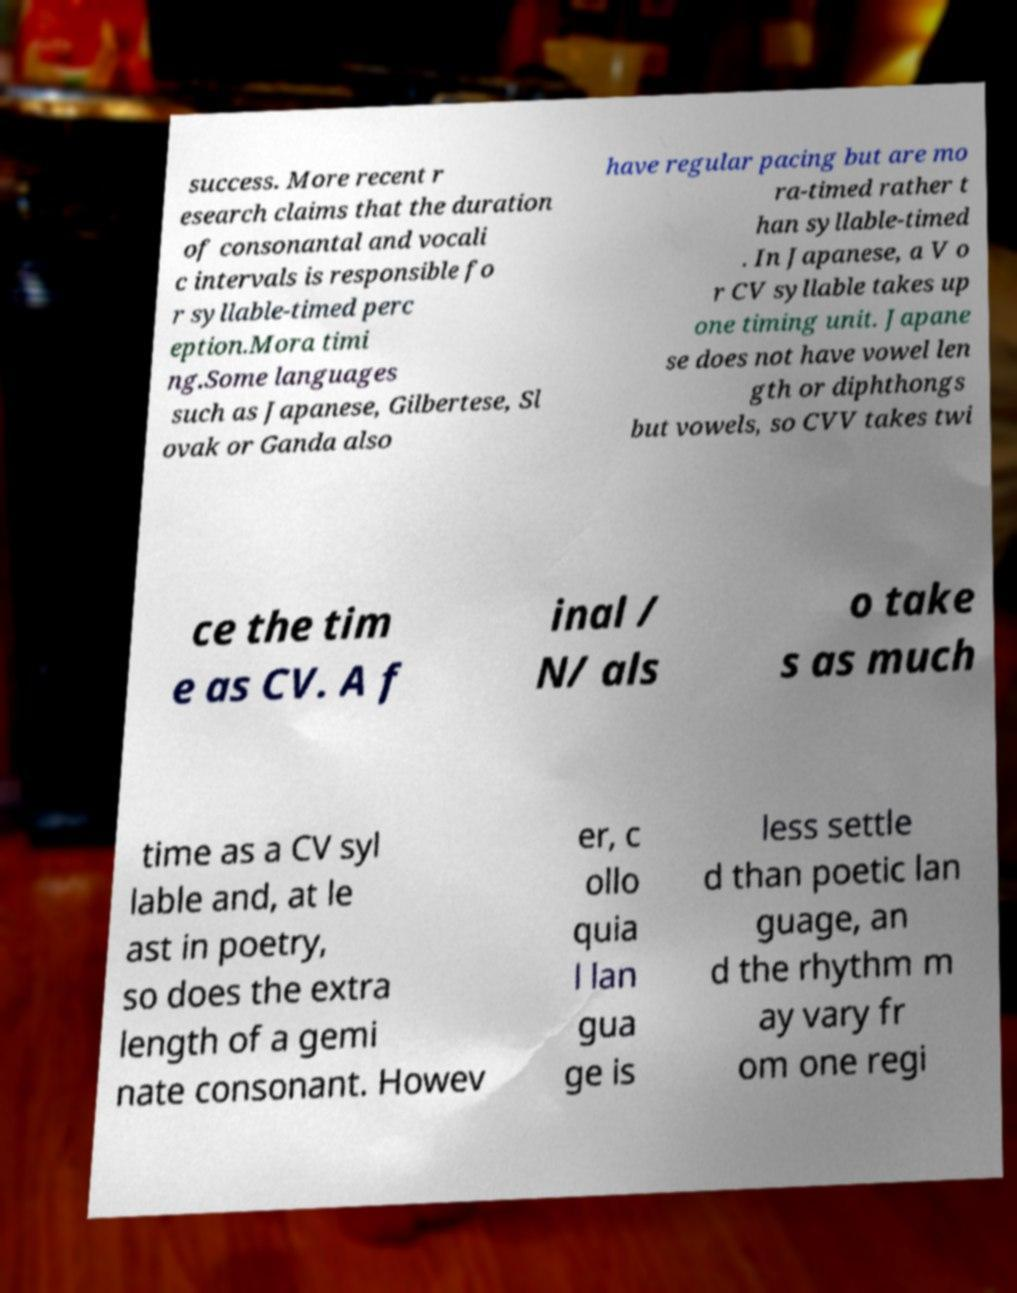Can you accurately transcribe the text from the provided image for me? success. More recent r esearch claims that the duration of consonantal and vocali c intervals is responsible fo r syllable-timed perc eption.Mora timi ng.Some languages such as Japanese, Gilbertese, Sl ovak or Ganda also have regular pacing but are mo ra-timed rather t han syllable-timed . In Japanese, a V o r CV syllable takes up one timing unit. Japane se does not have vowel len gth or diphthongs but vowels, so CVV takes twi ce the tim e as CV. A f inal / N/ als o take s as much time as a CV syl lable and, at le ast in poetry, so does the extra length of a gemi nate consonant. Howev er, c ollo quia l lan gua ge is less settle d than poetic lan guage, an d the rhythm m ay vary fr om one regi 